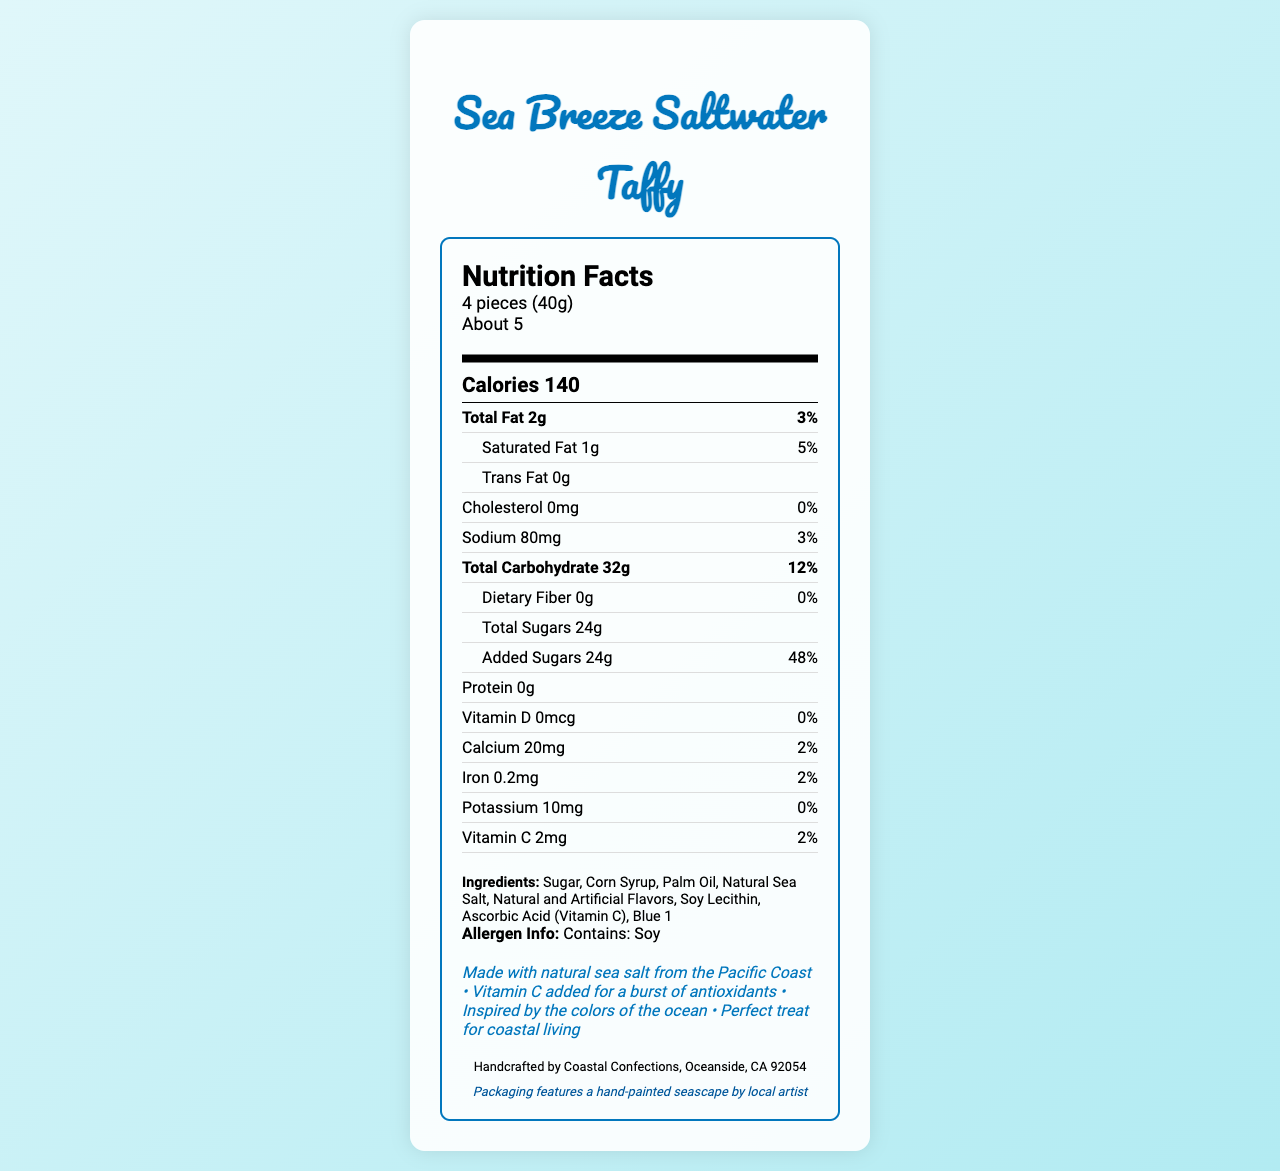how many calories are in a serving of Sea Breeze Saltwater Taffy? The document states that there are 140 calories per serving of Sea Breeze Saltwater Taffy.
Answer: 140 how many pieces are in a serving of Sea Breeze Saltwater Taffy? The serving size section of the document indicates that a serving consists of 4 pieces (40g).
Answer: 4 pieces what percentage of the daily value of calcium is provided in one serving of Sea Breeze Saltwater Taffy? The document shows that one serving contains 2mg of calcium, which is 2% of the daily value.
Answer: 2% how much sodium does one serving of Sea Breeze Saltwater Taffy contain? The sodium content per serving is listed as 80mg in the document.
Answer: 80mg what special feature of Sea Breeze Saltwater Taffy is inspired by the colors of the ocean? The special features section of the document mentions this specific feature.
Answer: The special feature inspired by the colors of the ocean is “Inspired by the colors of the ocean” which of the following is an ingredient in Sea Breeze Saltwater Taffy? A. Honey B. Natural Sea Salt C. Gelatin The ingredients list in the document includes Natural Sea Salt, and neither Honey nor Gelatin are mentioned.
Answer: B. Natural Sea Salt which vitamin is specifically added to Sea Breeze Saltwater Taffy for a burst of antioxidants? I. Vitamin D II. Vitamin C III. Vitamin A The special features highlight that Vitamin C is added for a burst of antioxidants.
Answer: II. Vitamin C does the packaging of Sea Breeze Saltwater Taffy feature artwork? The artist note section indicates that the packaging features a hand-painted seascape by a local artist.
Answer: Yes summarize the main idea of the document. The document outlines the nutritional details of Sea Breeze Saltwater Taffy, highlighting calories, fats, sugars, and vitamins, along with specific features like the use of natural sea salt, added vitamin C, and artistic packaging.
Answer: The document provides the nutritional information for Sea Breeze Saltwater Taffy, including macronutrient content, key vitamins and minerals, ingredients, allergen info, special features, and a mention of the packaging artwork. how many servings are there per container of Sea Breeze Saltwater Taffy? The document states that there are about 5 servings per container.
Answer: About 5 who handcrafts Sea Breeze Saltwater Taffy? The manufacturer info section lists Coastal Confections, based in Oceanside, CA, as the producer.
Answer: Coastal Confections, Oceanside, CA 92054 is Sea Breeze Saltwater Taffy gluten-free? The document does not provide any information regarding the gluten content of Sea Breeze Saltwater Taffy.
Answer: Cannot be determined 